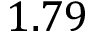Convert formula to latex. <formula><loc_0><loc_0><loc_500><loc_500>1 . 7 9</formula> 